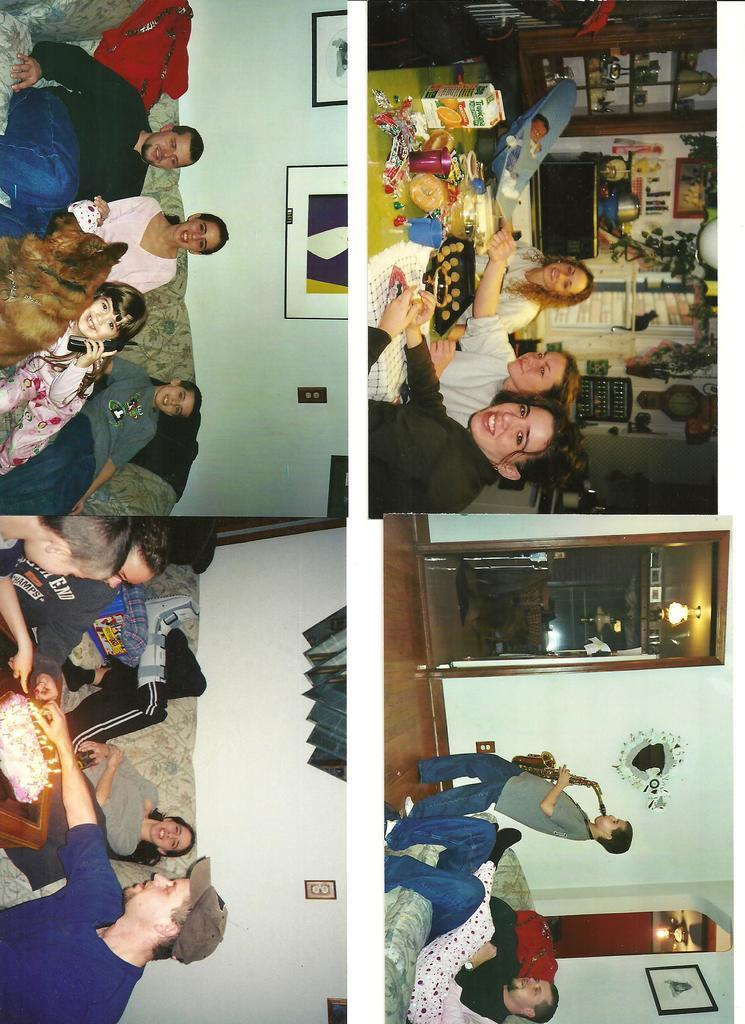What type of image is being described? The image is a photo collage. What can be found within the photo collage? There are people in the photos within the collage. How quiet is the environment in the photo collage? The provided facts do not give any information about the environment's quietness or noise level in the photo collage. 